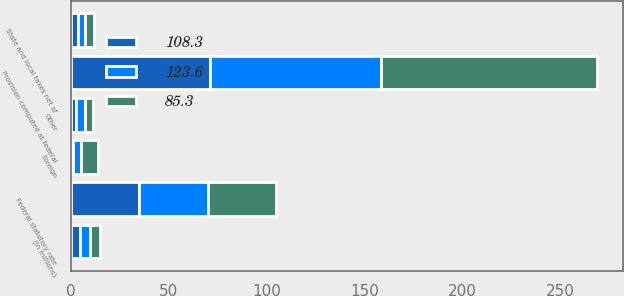Convert chart to OTSL. <chart><loc_0><loc_0><loc_500><loc_500><stacked_bar_chart><ecel><fcel>(In millions)<fcel>Federal statutory rate<fcel>Provision computed at federal<fcel>State and local taxes net of<fcel>Foreign<fcel>Other<nl><fcel>85.3<fcel>5<fcel>35<fcel>110.2<fcel>5<fcel>8.8<fcel>3.9<nl><fcel>108.3<fcel>5<fcel>35<fcel>70.9<fcel>3.8<fcel>1.3<fcel>2.6<nl><fcel>123.6<fcel>5<fcel>35<fcel>87.3<fcel>3.3<fcel>4<fcel>4.9<nl></chart> 